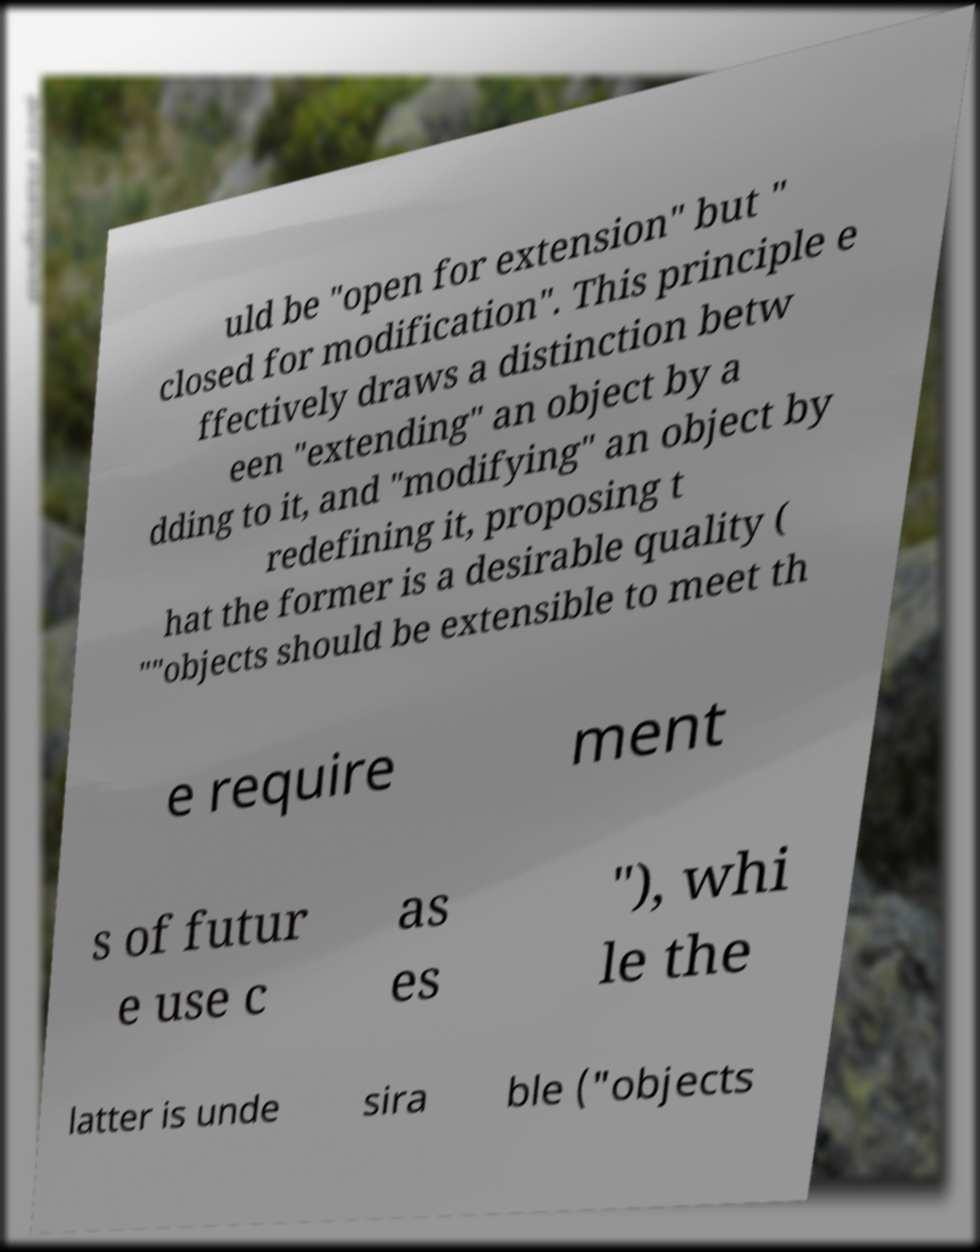I need the written content from this picture converted into text. Can you do that? uld be "open for extension" but " closed for modification". This principle e ffectively draws a distinction betw een "extending" an object by a dding to it, and "modifying" an object by redefining it, proposing t hat the former is a desirable quality ( ""objects should be extensible to meet th e require ment s of futur e use c as es "), whi le the latter is unde sira ble ("objects 